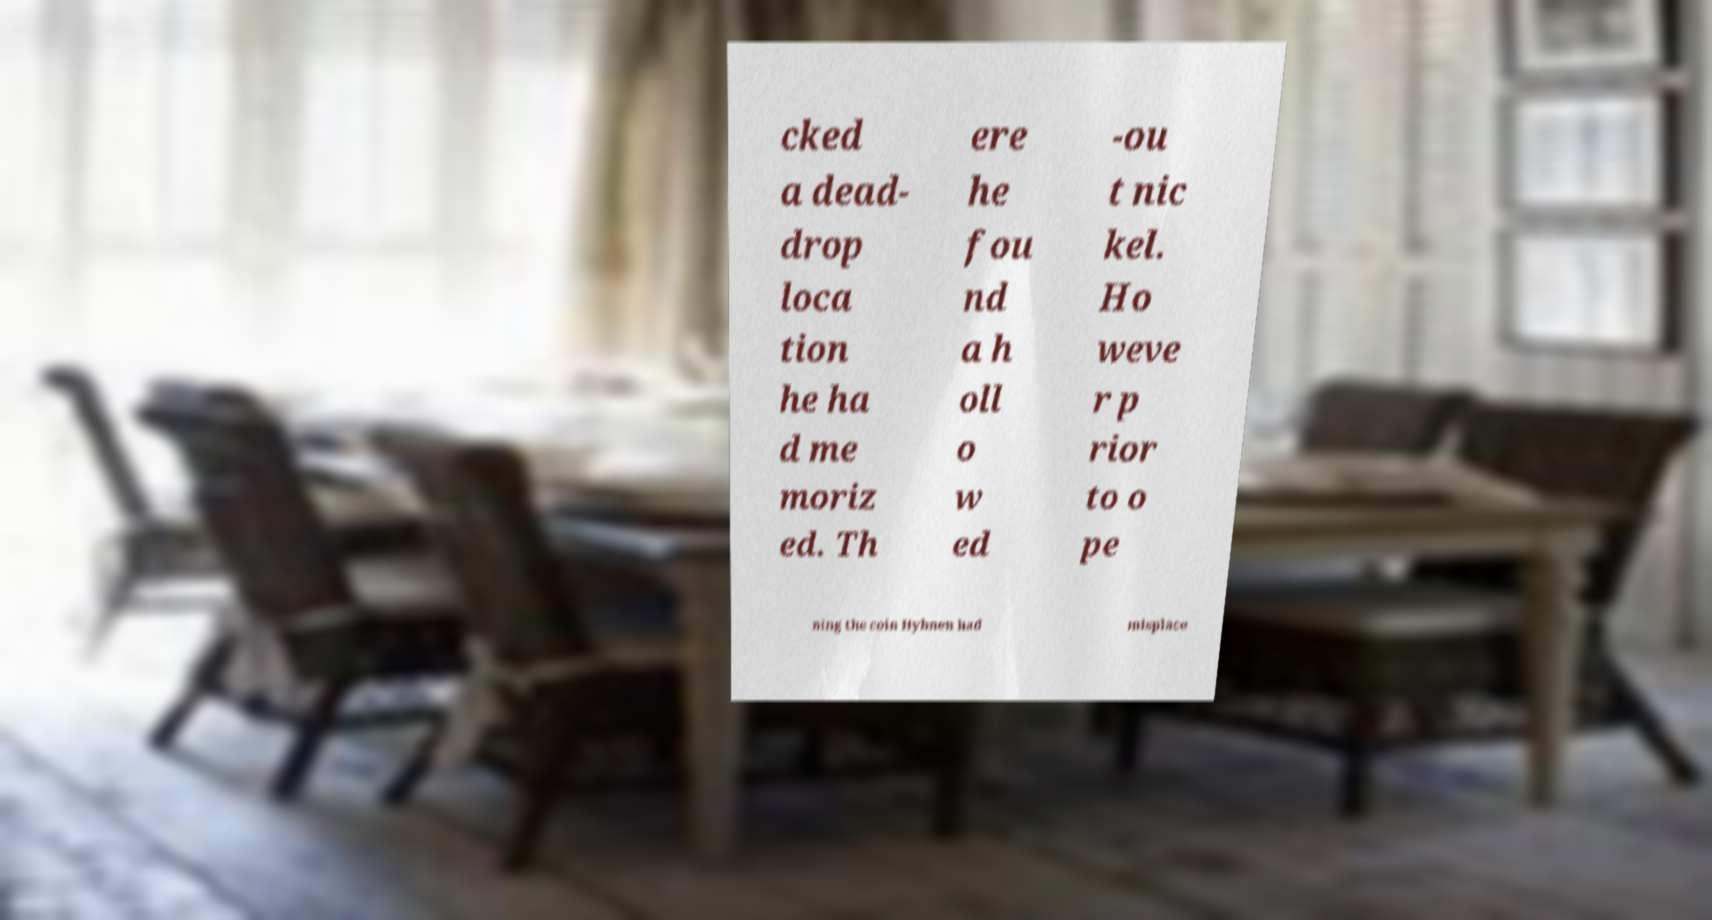Can you read and provide the text displayed in the image?This photo seems to have some interesting text. Can you extract and type it out for me? cked a dead- drop loca tion he ha d me moriz ed. Th ere he fou nd a h oll o w ed -ou t nic kel. Ho weve r p rior to o pe ning the coin Hyhnen had misplace 